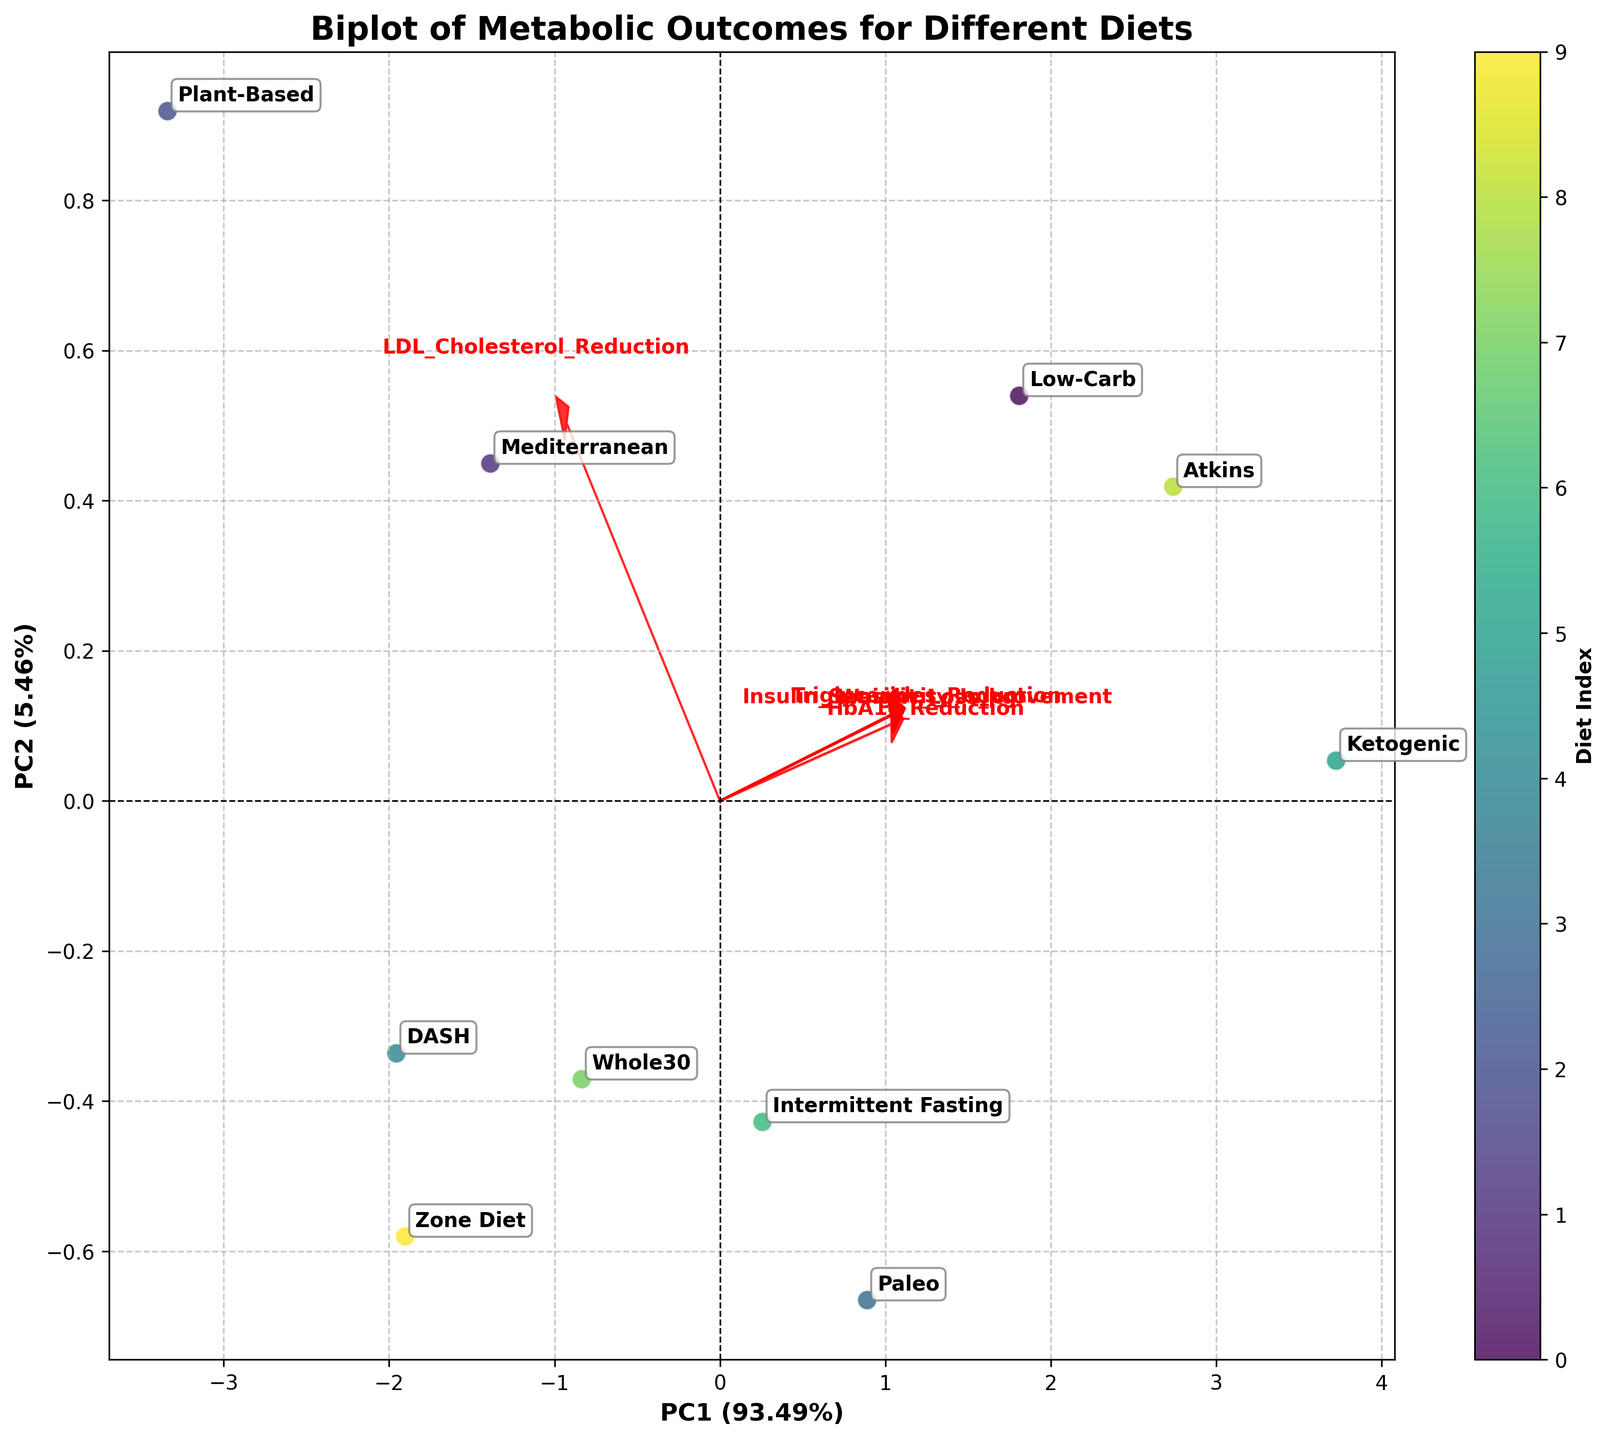What does the x-axis represent in the biplot? The x-axis represents the first principal component (PC1) which accounts for a certain percentage of the total variance in the data, as indicated by the label.
Answer: PC1 Which diet has the highest weight loss according to the biplot? According to the annotation and positioning in the biplot, the diet labeled "Ketogenic" shows the highest weight loss among the diets.
Answer: Ketogenic How do the plant-based and Mediterranean diets compare in terms of insulin sensitivity improvement? To compare insulin sensitivity improvement, observe the directions and lengths of the feature arrows in relation to the diet points. Both the plant-based and Mediterranean diets point moderately in the direction of the insulin sensitivity improvement vector, but the Mediterranean diet is slightly closer.
Answer: Mediterranean Is there a diet that substantially improves both weight loss and triglycerides reduction? By observing the positions of diets in relation to the arrows for weight loss and triglycerides reduction, the Ketogenic and Low-Carb diets are near these vectors indicating substantial improvements in both criteria.
Answer: Ketogenic and Low-Carb Which feature has a negative correlation with the second principal component (PC2)? By observing the direction of the feature arrows, any vector pointing downwards with respect to the PC2 axis has a negative correlation with PC2. Here, "LDL Cholesterol Reduction" has a somewhat downward direction.
Answer: LDL Cholesterol Reduction Can you identify two diets that are most dissimilar in terms of the principal components? Look for diets that are farthest apart in the biplot. The Ketogenic and Plant-Based diets are positioned far from each other, indicating dissimilar outcomes based on the PC analysis.
Answer: Ketogenic and Plant-Based Do any diets appear very close to the origin point (0,0) in the biplot, indicating minimal influence by the principal components? The Whole30 diet appears very close to the origin, suggesting it has minimal influence by both principal components PC1 and PC2.
Answer: Whole30 Which diet shows a stronger correlation with triglyceride reduction compared to others? Observing the vectors and diet positions, the Ketogenic and Low-Carb diets are pointed more strongly in the direction of the triglycerides reduction vector.
Answer: Ketogenic and Low-Carb Is weight loss more positively or negatively correlated with PC1? The vector for "Weight_Loss_kg" points strongly in the positive direction of PC1, indicating a positive correlation.
Answer: Positively 